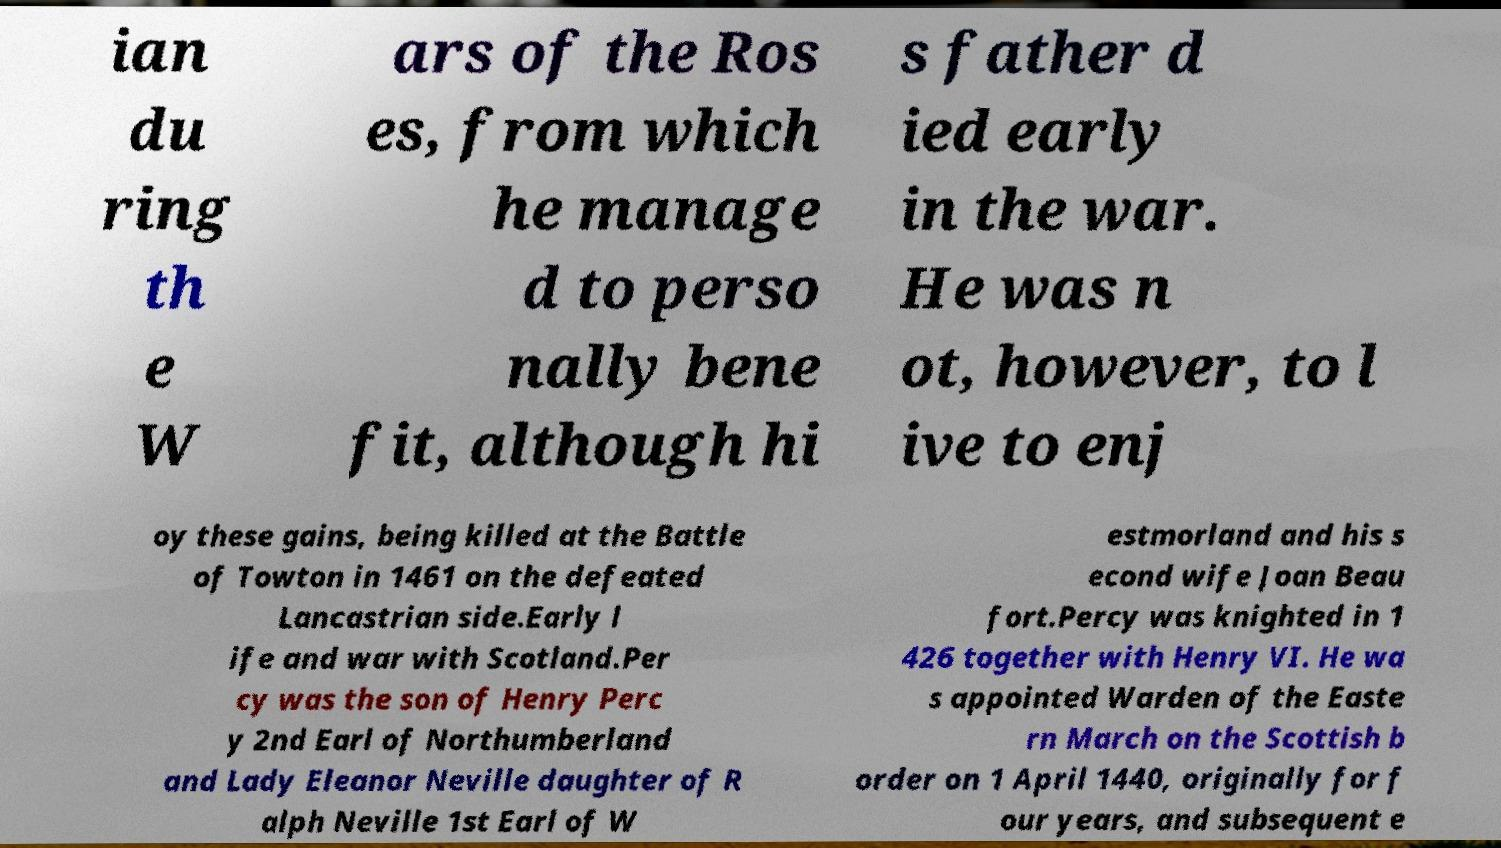For documentation purposes, I need the text within this image transcribed. Could you provide that? ian du ring th e W ars of the Ros es, from which he manage d to perso nally bene fit, although hi s father d ied early in the war. He was n ot, however, to l ive to enj oy these gains, being killed at the Battle of Towton in 1461 on the defeated Lancastrian side.Early l ife and war with Scotland.Per cy was the son of Henry Perc y 2nd Earl of Northumberland and Lady Eleanor Neville daughter of R alph Neville 1st Earl of W estmorland and his s econd wife Joan Beau fort.Percy was knighted in 1 426 together with Henry VI. He wa s appointed Warden of the Easte rn March on the Scottish b order on 1 April 1440, originally for f our years, and subsequent e 